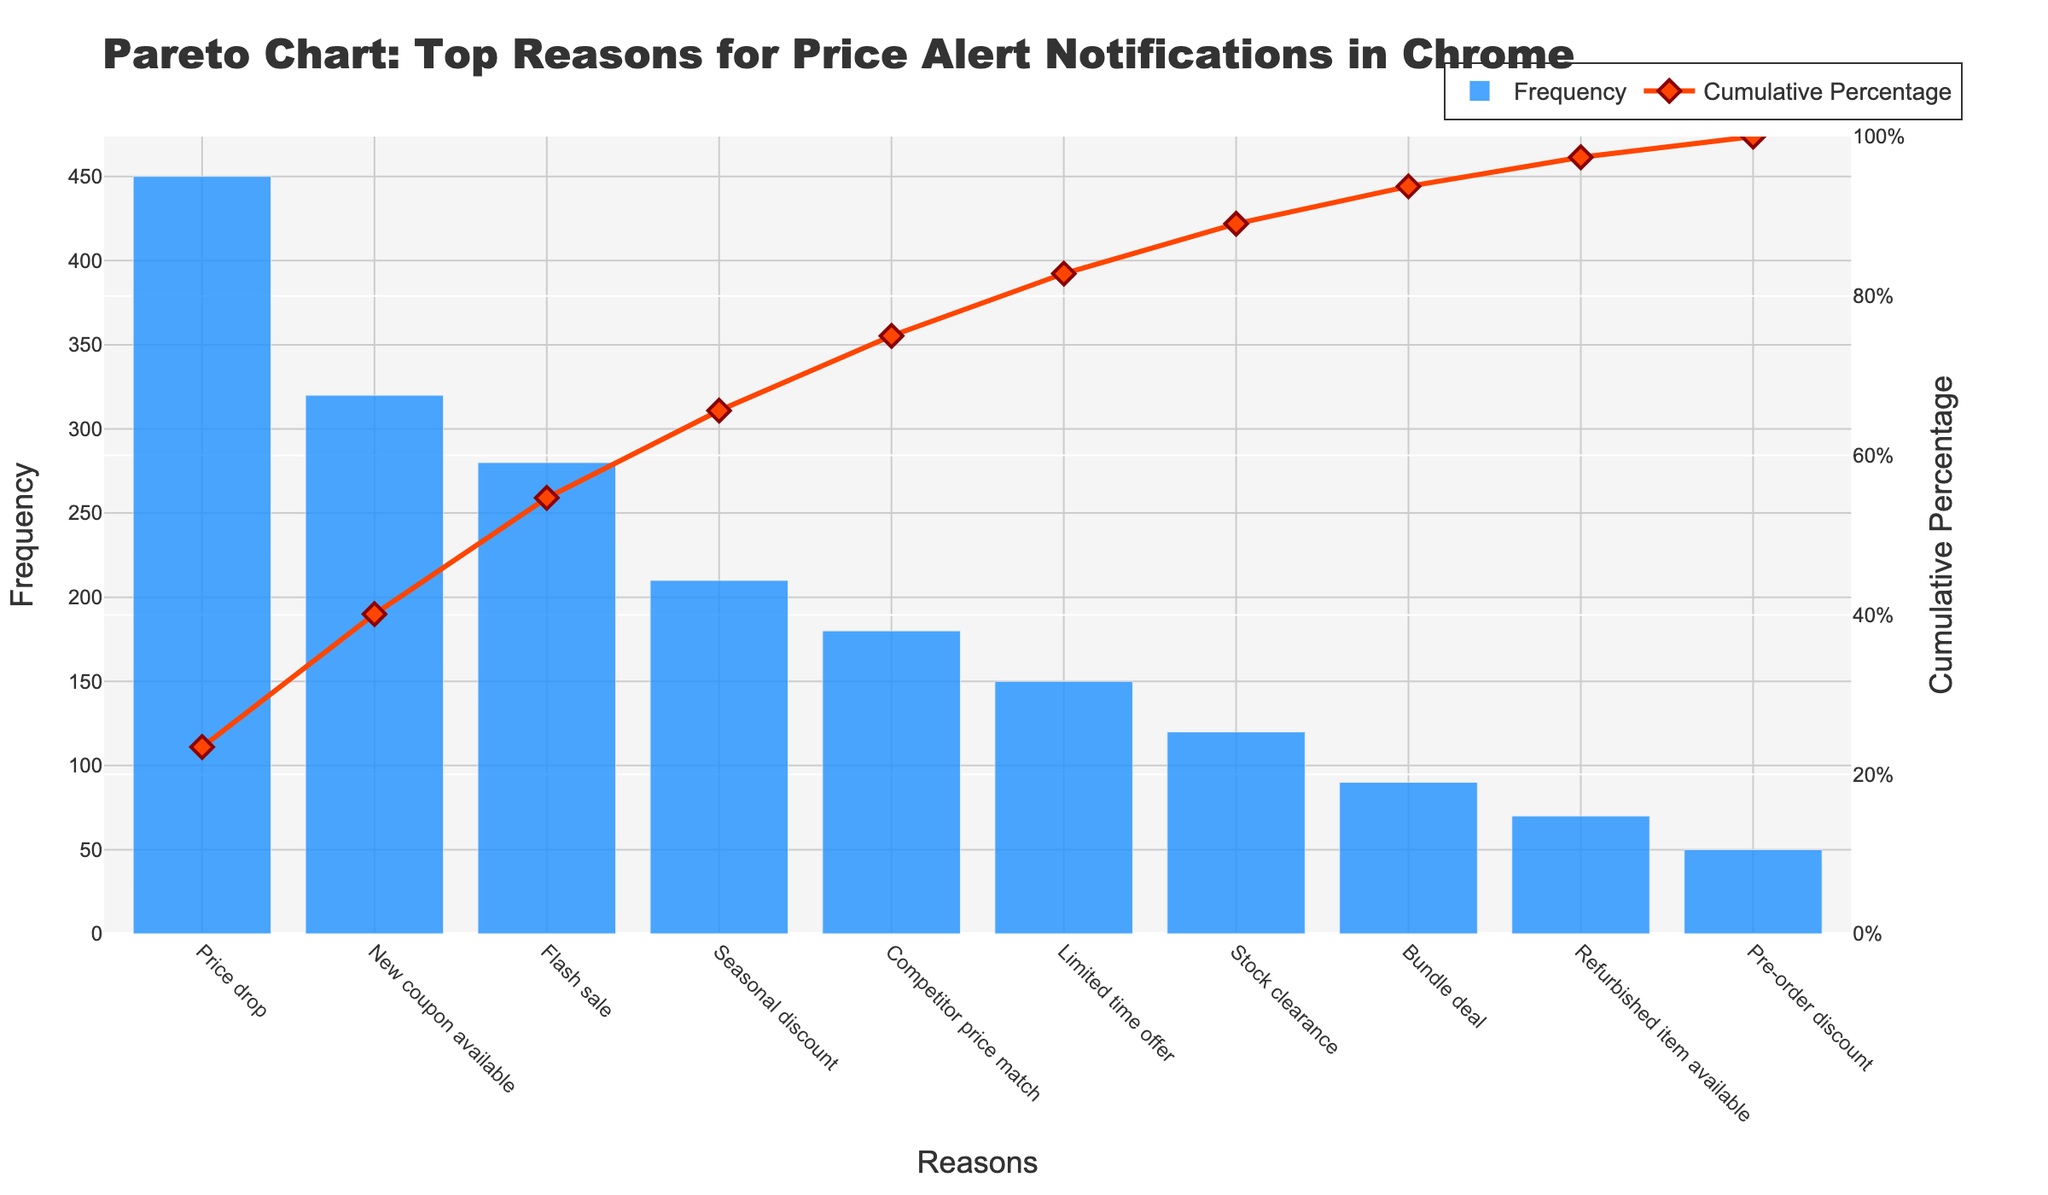What is the title of the figure? The title is usually positioned at the top of the figure and indicates the main subject of the chart. In this case, it is "Pareto Chart: Top Reasons for Price Alert Notifications in Chrome".
Answer: Pareto Chart: Top Reasons for Price Alert Notifications in Chrome How many different reasons for price alert notifications are shown in the chart? By counting the individual bars along the x-axis, we can see that there are 10 different reasons presented on the chart.
Answer: 10 Which reason has the highest frequency of price alert notifications? The highest bar in the bar chart represents the most frequent reason for price alerts, which is "Price drop".
Answer: Price drop What is the frequency for the "Flash sale" reason? Locate the bar corresponding to "Flash sale" on the x-axis and check the y-axis value for its height, which is 280.
Answer: 280 What is the cumulative percentage when you add up frequencies up to and including "New coupon available"? Calculate the cumulative percentage by summing the frequencies of reasons up to "New coupon available" (450 + 320) and then divide by the total frequency, converting it to a percentage. So, (450 + 320) / (450 + 320 + 280 + 210 + 180 + 150 + 120 + 90 + 70 + 50) * 100 = 53.3%.
Answer: 53.3% Which reason has the lowest frequency of price alert notifications? The lowest bar in the bar chart represents the least frequent reason for price alerts, which is "Pre-order discount".
Answer: Pre-order discount What percentage of notifications is accounted for by the top three reasons? Calculate the sum of the frequencies for the top three reasons (450 + 320 + 280) and divide it by the total frequency to get the percentage: (450 + 320 + 280) / (450 + 320 + 280 + 210 + 180 + 150 + 120 + 90 + 70 + 50) * 100 = 66.3%.
Answer: 66.3% Which reason marks the point where the cumulative percentage first exceeds 80%? Monitor the cumulative percentage values along the line until it first exceeds 80%, which happens at "Stock clearance".
Answer: Stock clearance How does the cumulative percentage line visually indicate that it has reached 100%? The cumulative percentage line reaches the top or maximum on the y-axis secondary scale (100%), ending on the rightmost point corresponding with the last reason.
Answer: Reaches the top Compare the frequency of "Seasonal discount" and "Competitor price match". Which one is higher? From the heights of the bars corresponding to these reasons, "Seasonal discount" has a frequency of 210, while "Competitor price match" has a frequency of 180, so "Seasonal discount" is higher.
Answer: Seasonal discount 